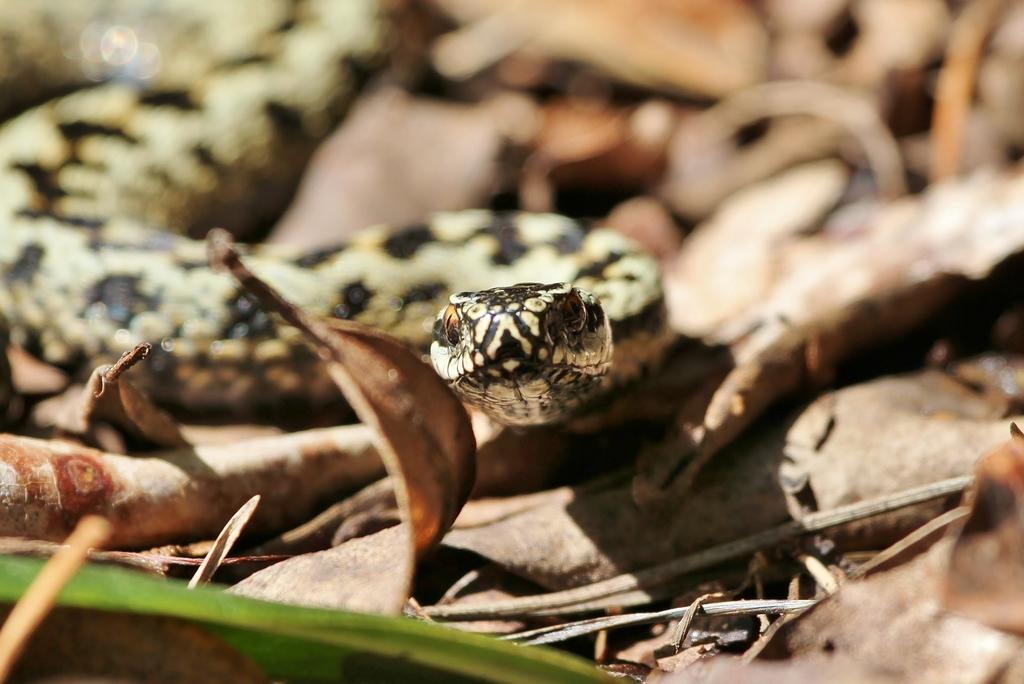What type of animal is in the picture? There is a snake in the picture. What can be seen at the bottom of the image? Dried leaves are present at the bottom of the image. What other objects are visible in the image? There are sticks in the image. What arm is the snake using to hold the sister in the image? There is no sister or arm present in the image; it only features a snake and some sticks. 